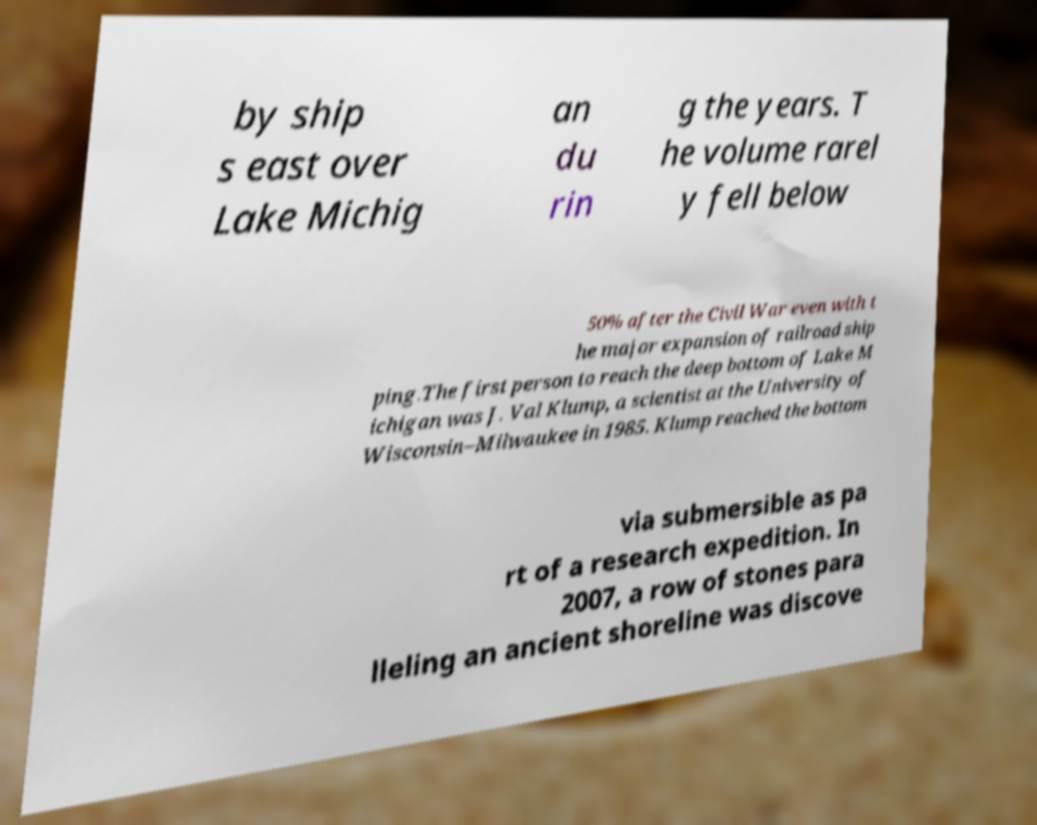Please read and relay the text visible in this image. What does it say? by ship s east over Lake Michig an du rin g the years. T he volume rarel y fell below 50% after the Civil War even with t he major expansion of railroad ship ping.The first person to reach the deep bottom of Lake M ichigan was J. Val Klump, a scientist at the University of Wisconsin–Milwaukee in 1985. Klump reached the bottom via submersible as pa rt of a research expedition. In 2007, a row of stones para lleling an ancient shoreline was discove 